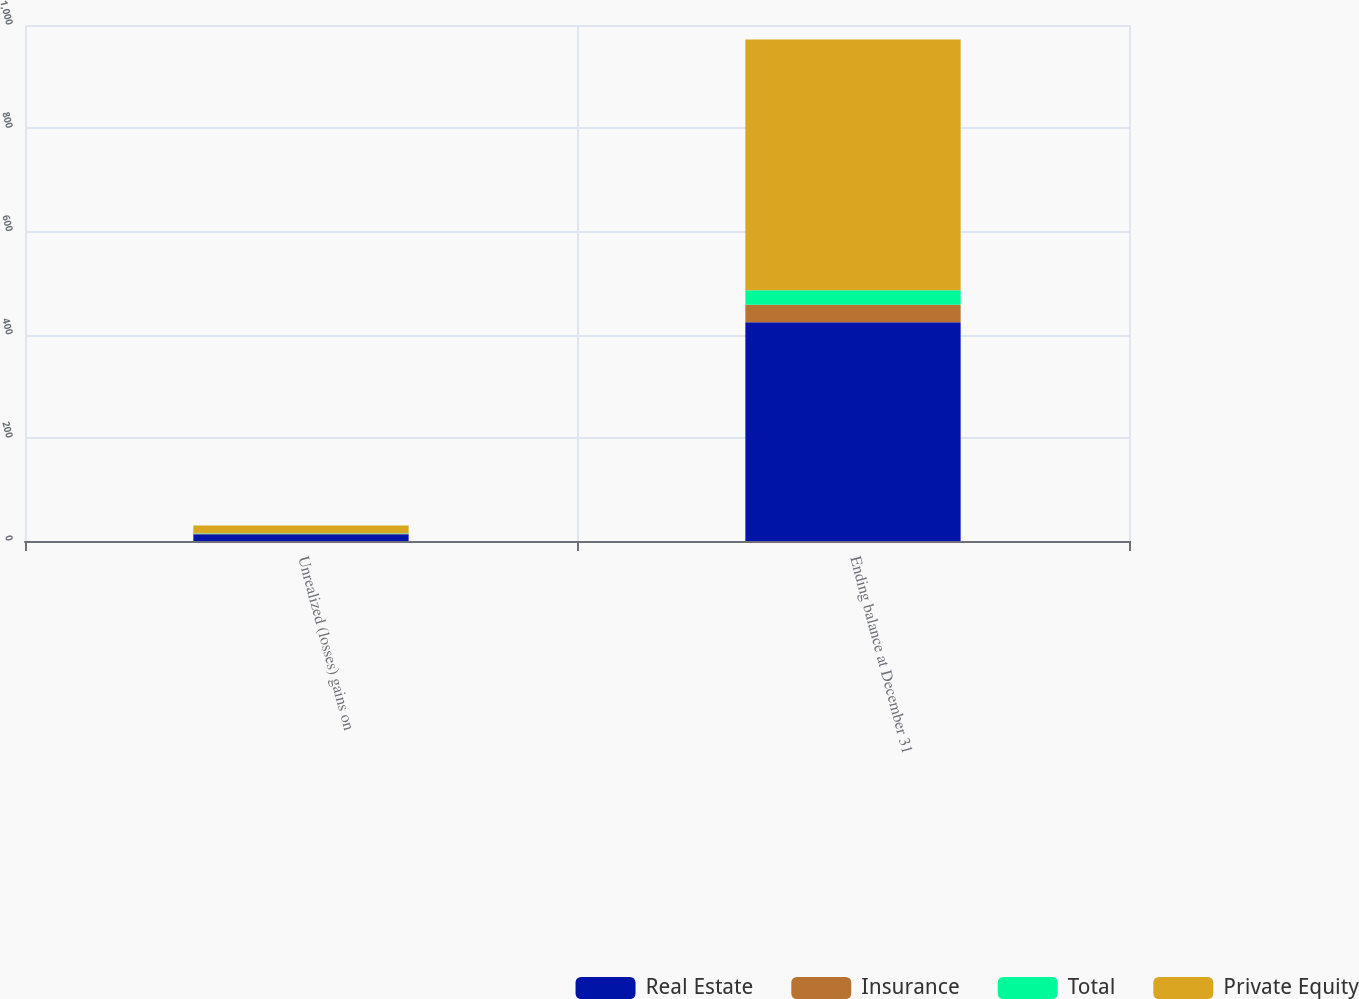<chart> <loc_0><loc_0><loc_500><loc_500><stacked_bar_chart><ecel><fcel>Unrealized (losses) gains on<fcel>Ending balance at December 31<nl><fcel>Real Estate<fcel>13<fcel>424<nl><fcel>Insurance<fcel>1<fcel>34<nl><fcel>Total<fcel>1<fcel>28<nl><fcel>Private Equity<fcel>15<fcel>486<nl></chart> 